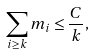<formula> <loc_0><loc_0><loc_500><loc_500>\sum _ { i \geq k } m _ { i } \leq \frac { C } { k } ,</formula> 